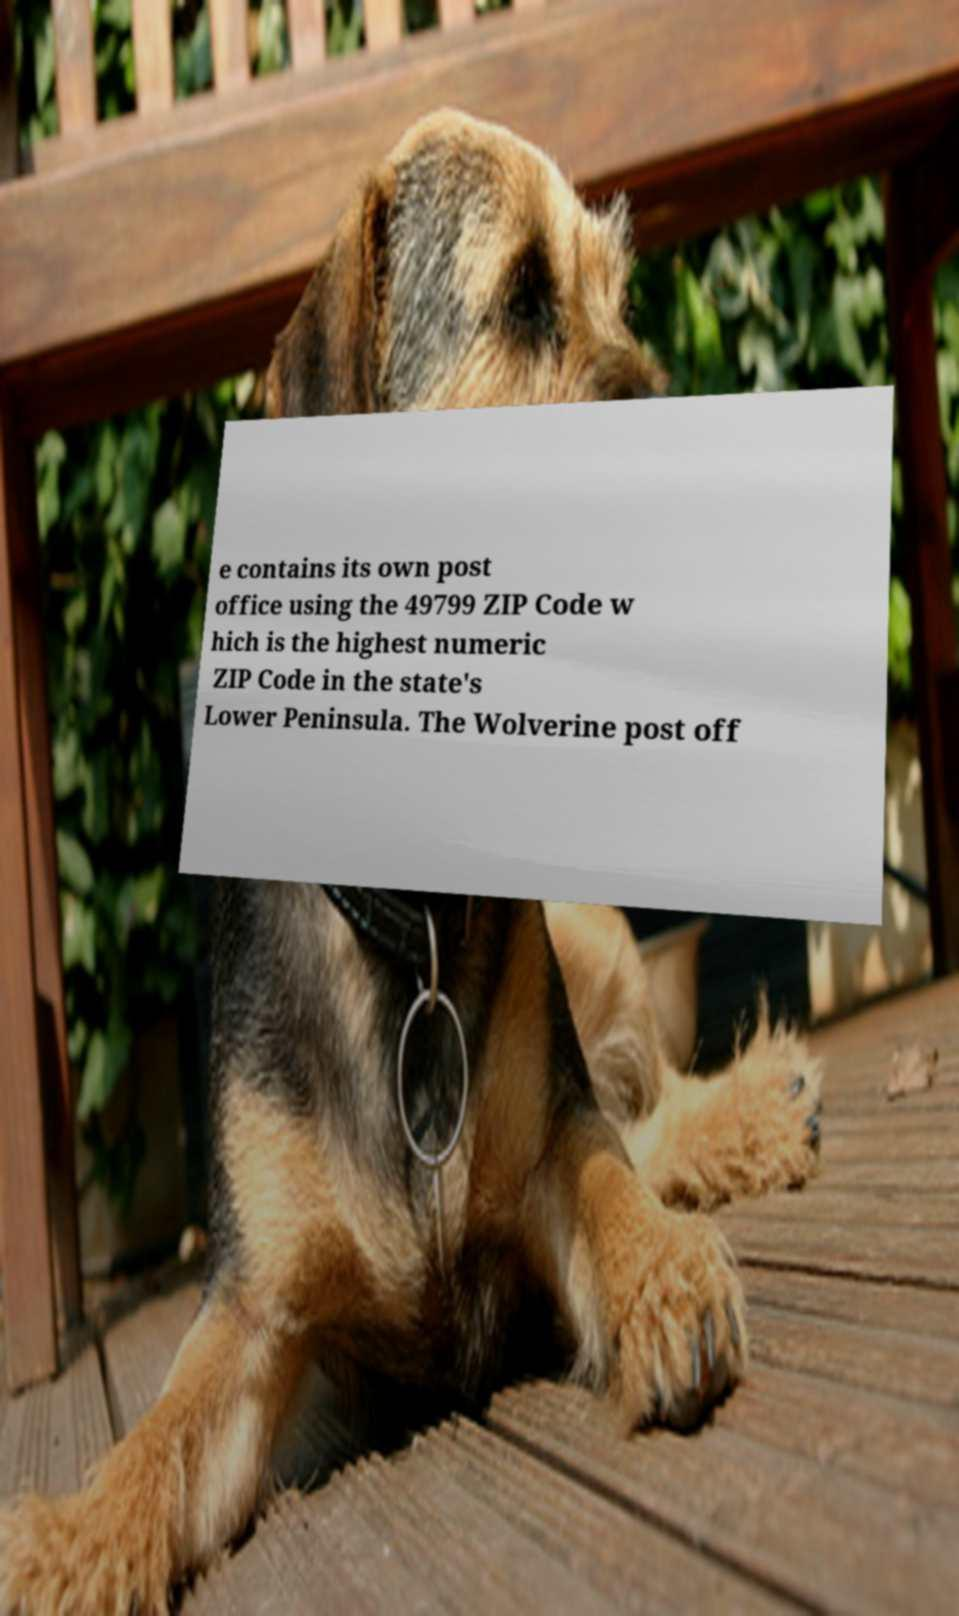Can you read and provide the text displayed in the image?This photo seems to have some interesting text. Can you extract and type it out for me? e contains its own post office using the 49799 ZIP Code w hich is the highest numeric ZIP Code in the state's Lower Peninsula. The Wolverine post off 